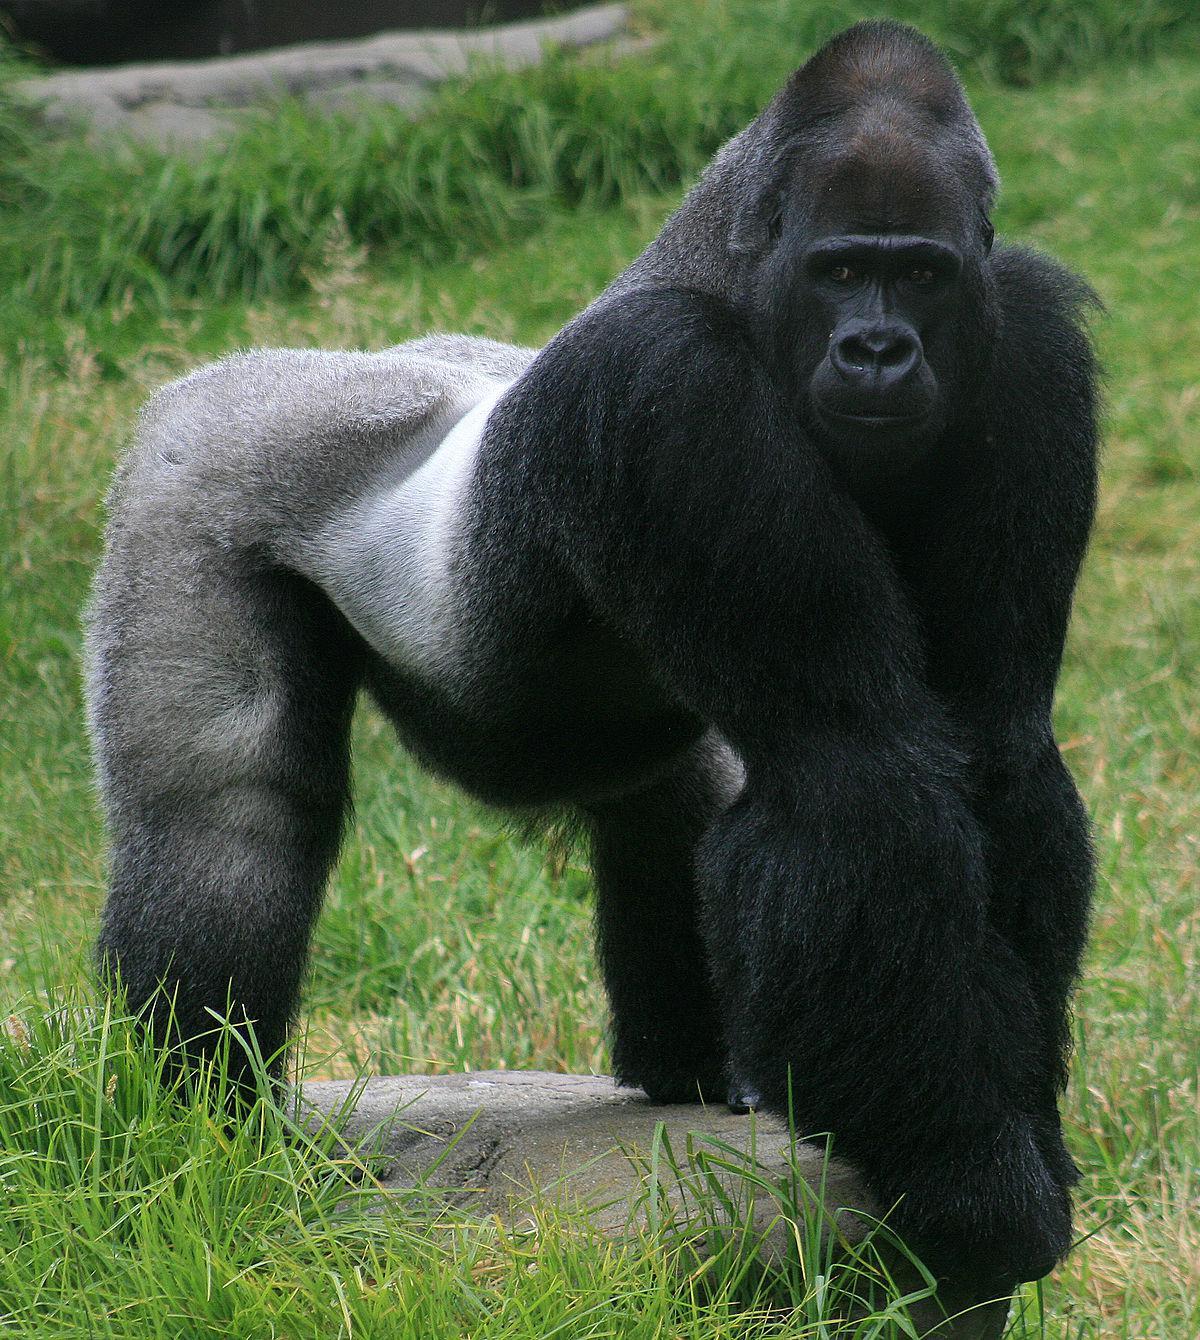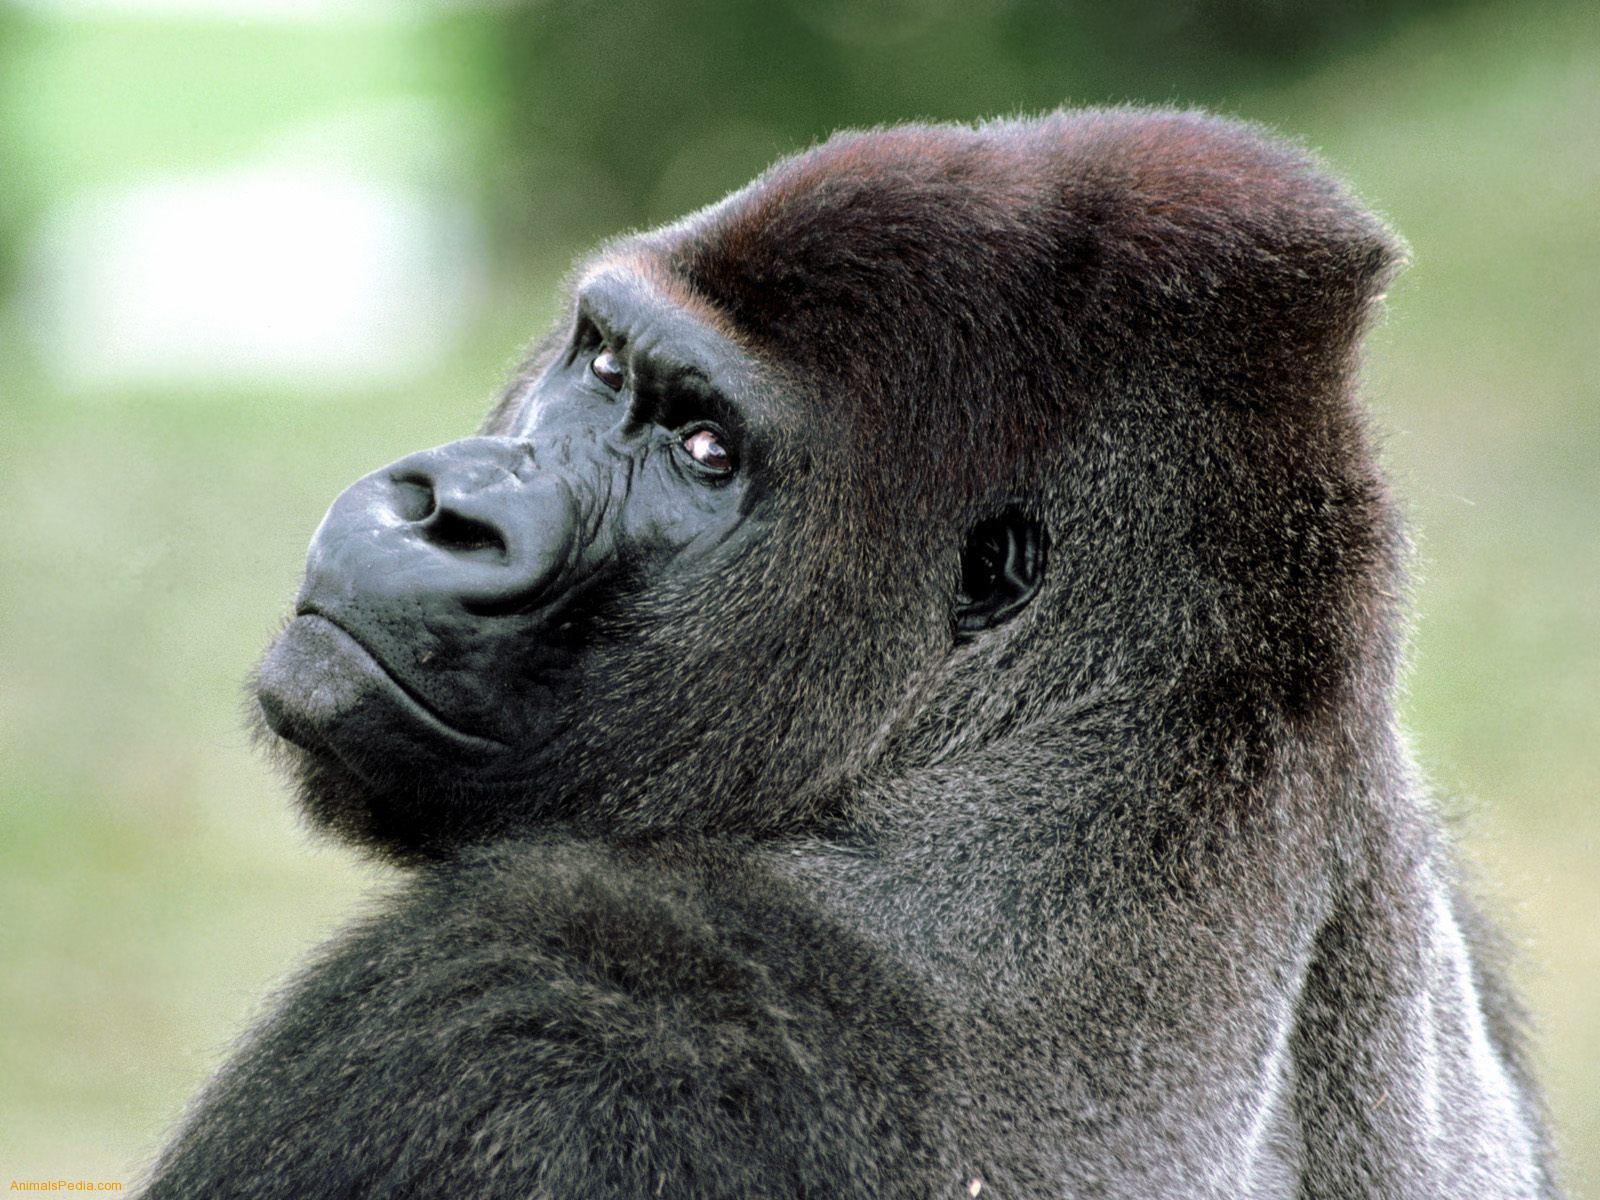The first image is the image on the left, the second image is the image on the right. Analyze the images presented: Is the assertion "One image includes a baby gorilla with its mother." valid? Answer yes or no. No. 